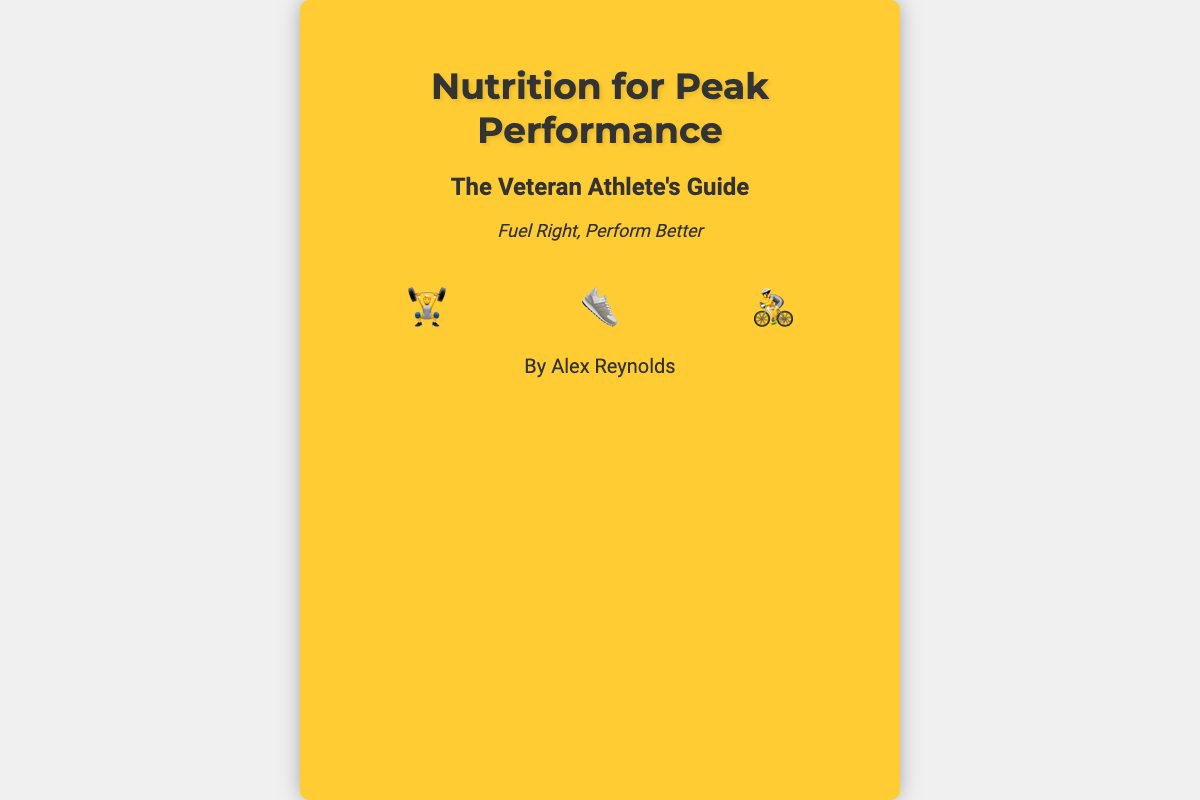what is the title of the book? The title of the book is prominently displayed at the top of the cover.
Answer: Nutrition for Peak Performance who is the author of the book? The author's name is found near the bottom of the cover.
Answer: Alex Reynolds what is the tagline of the book? The tagline can be found just below the subtitle, summarizing the book's main focus.
Answer: Fuel Right, Perform Better what type of foods are featured on the cover? The cover includes illustrations of high-energy foods embedded in its design.
Answer: Banana, Almond, Chia how many icons representing training are on the cover? The number of training icons is visible in the icons section at the bottom of the content area.
Answer: Three what color is the background of the book cover? The background color is a significant design element that can be seen immediately.
Answer: Yellow what font style is used for the main title? The font style can be identified by observing the text elements on the cover.
Answer: Montserrat what images are used as food representations? The cover features distinct food illustrations that support the book's theme.
Answer: Banana, Almond, Chia 